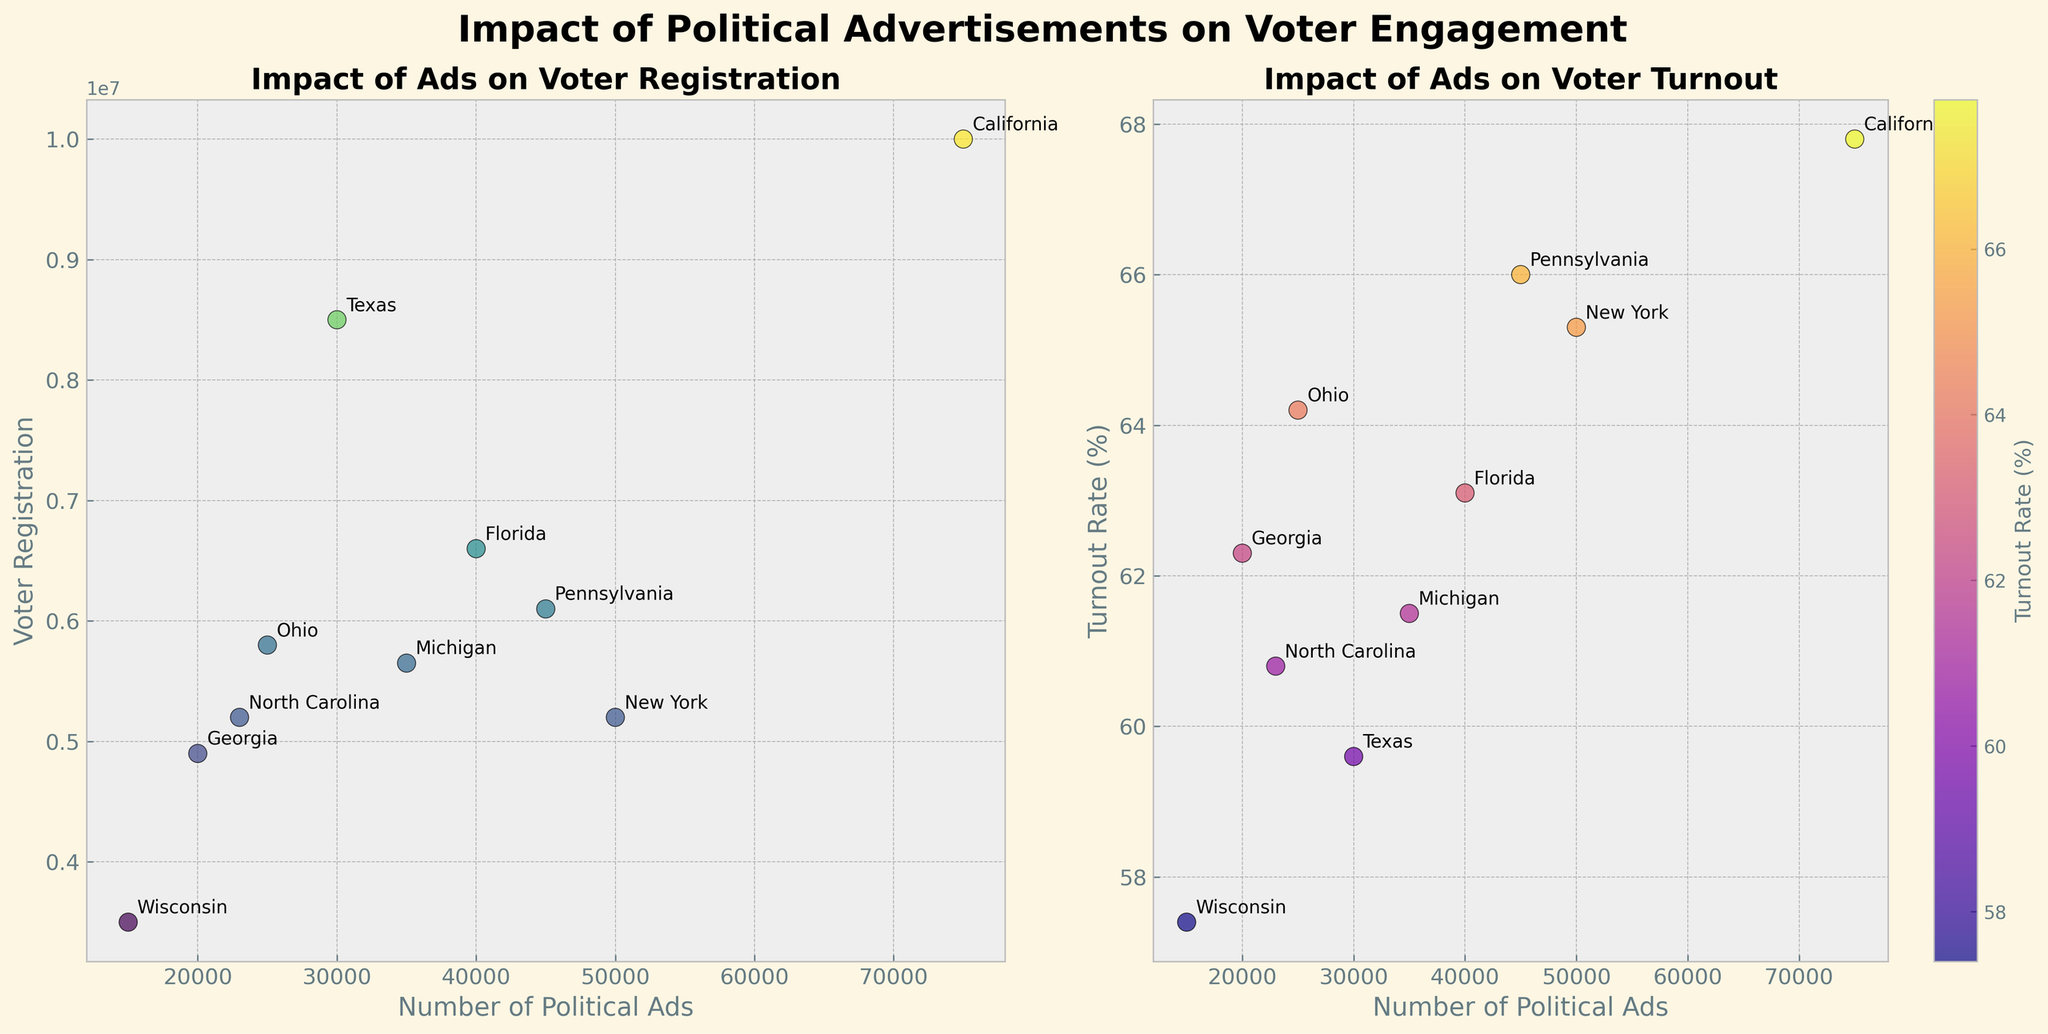How many states are represented in the plot? To find this, count the number of unique state names annotated in the plot.
Answer: 10 What is the title of the left subplot? The title is displayed above the left scatter plot.
Answer: Impact of Ads on Voter Registration Which state has the highest turnout rate? By examining the right scatter plot and the annotations, identify the state with the highest y-axis value representing turnout rate.
Answer: California What is the smallest number of political ads aired among the states? Check the x-axis values on both scatter plots for the smallest value.
Answer: 15,000 What's the difference in turnout rates between Florida and Ohio? Subtract the turnout rate of Ohio from that of Florida. Florida has a turnout rate of 63.1%, and Ohio has 64.2%. So, 63.1 - 64.2 = -1.1.
Answer: -1.1 Which state appears to have the lowest voter registration despite airing a high number of political ads? Compare the number of political ads on the x-axis and voter registration on the y-axis in the left plot. Identify the state with low y-value but high x-value.
Answer: New York What is the average voter registration across all states shown? Sum up all voter registration values and divide by the number of states. Calculation: (5200000 + 10000000 + 8500000 + 6600000 + 5800000 + 5650000 + 6100000 + 4900000 + 5200000 + 3500000) / 10.
Answer: 6640000 Is there a noticeable trend between the number of political ads aired and voter turnout rates? Examine the right plot to determine if there's a visible relationship or pattern between the number of ads and turnout rates.
Answer: No clear trend Describe the color mapping used for the turnout rate in the right scatter plot. Refer to the color used in the scatter plot and the color bar to explain how different turnout rates are associated with different colors.
Answer: The higher the turnout rate, the warmer (more red) the color; the lower the rate, the cooler (more blue) the color Which state has a similar number of political ads aired but a significantly different turnout rate compared to Georgia? Identify states with similar x-axis values for political ads in the right plot and compare their y-axis values for turnout rates with Georgia.
Answer: North Carolina 